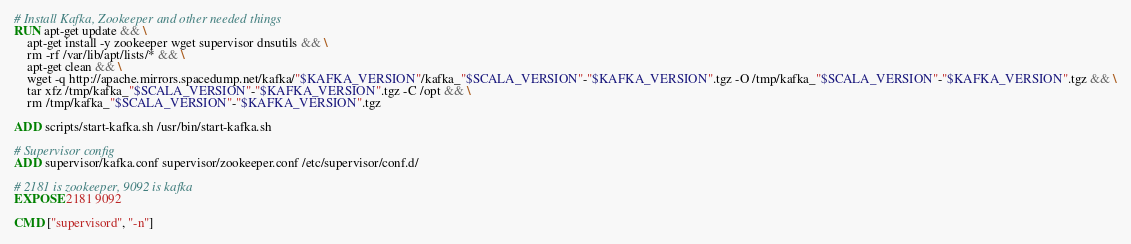<code> <loc_0><loc_0><loc_500><loc_500><_Dockerfile_># Install Kafka, Zookeeper and other needed things
RUN apt-get update && \
    apt-get install -y zookeeper wget supervisor dnsutils && \
    rm -rf /var/lib/apt/lists/* && \
    apt-get clean && \
    wget -q http://apache.mirrors.spacedump.net/kafka/"$KAFKA_VERSION"/kafka_"$SCALA_VERSION"-"$KAFKA_VERSION".tgz -O /tmp/kafka_"$SCALA_VERSION"-"$KAFKA_VERSION".tgz && \
    tar xfz /tmp/kafka_"$SCALA_VERSION"-"$KAFKA_VERSION".tgz -C /opt && \
    rm /tmp/kafka_"$SCALA_VERSION"-"$KAFKA_VERSION".tgz

ADD scripts/start-kafka.sh /usr/bin/start-kafka.sh

# Supervisor config
ADD supervisor/kafka.conf supervisor/zookeeper.conf /etc/supervisor/conf.d/

# 2181 is zookeeper, 9092 is kafka
EXPOSE 2181 9092

CMD ["supervisord", "-n"]
</code> 